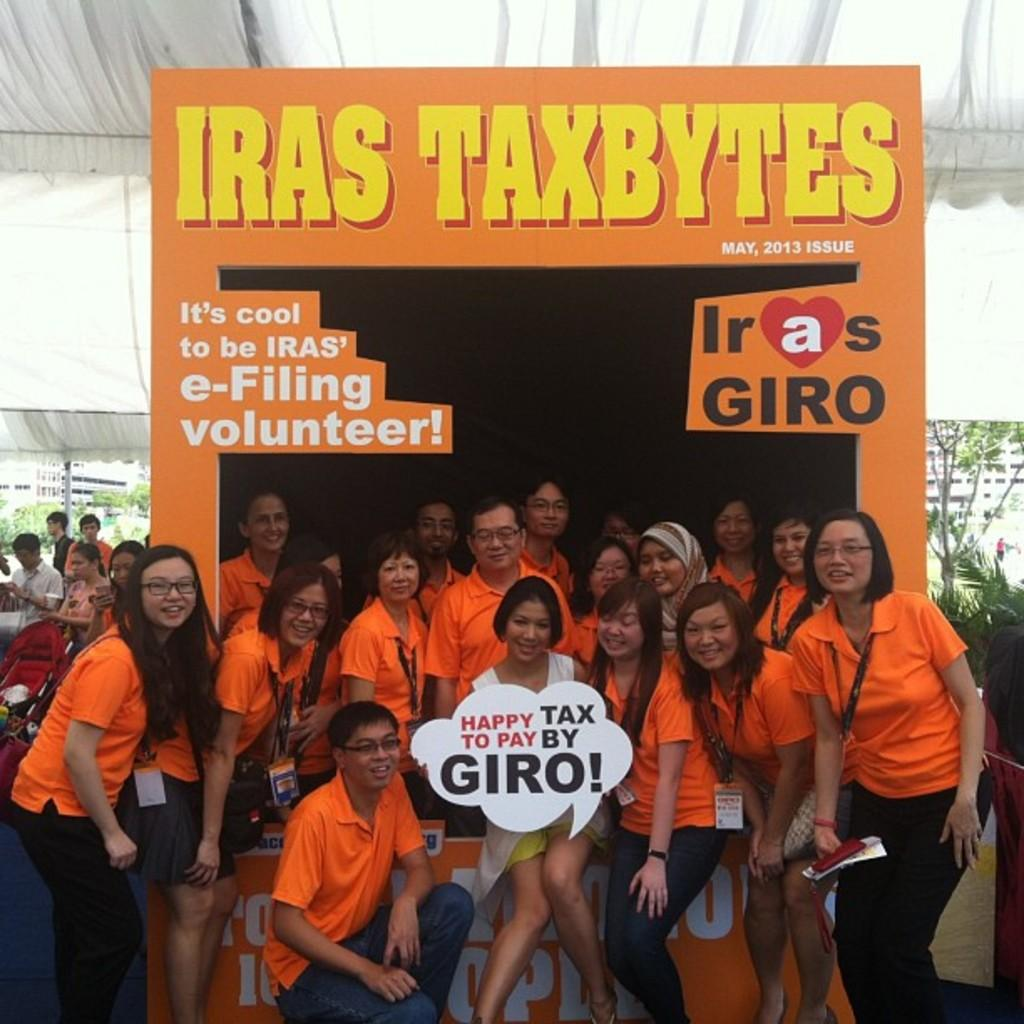How many people are in the image? There are many people in the image. What are the people wearing in the image? The people are wearing orange t-shirts. What are the people doing in the image? The people are looking at someone. What type of bread is being served to the people in the image? There is no bread present in the image. Is eggnog being shared among the people in the image? There is no eggnog present in the image. What type of scale is being used to weigh the people in the image? There is no scale present in the image, and the people are not being weighed. 